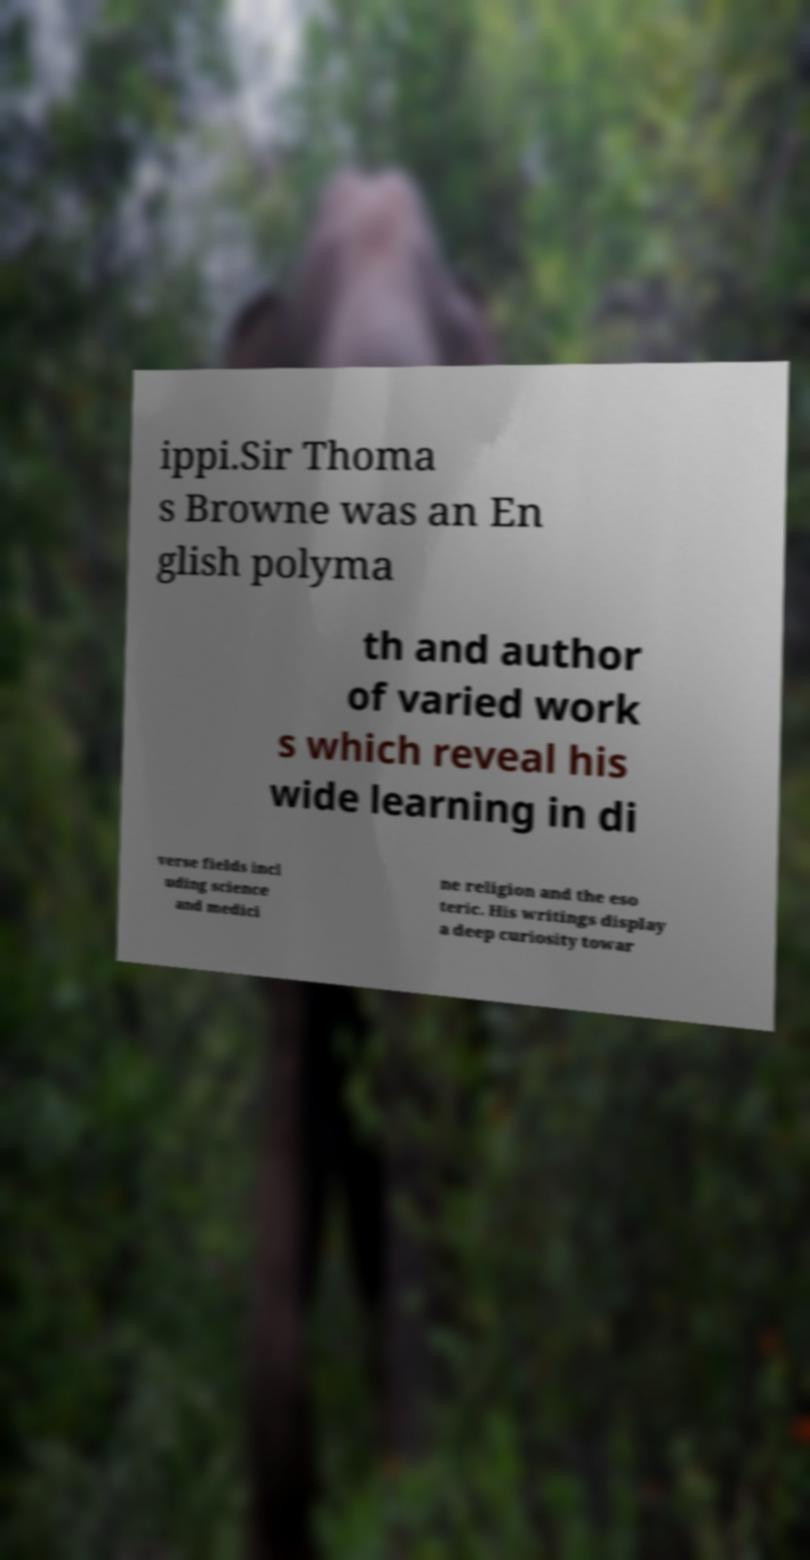Could you assist in decoding the text presented in this image and type it out clearly? ippi.Sir Thoma s Browne was an En glish polyma th and author of varied work s which reveal his wide learning in di verse fields incl uding science and medici ne religion and the eso teric. His writings display a deep curiosity towar 